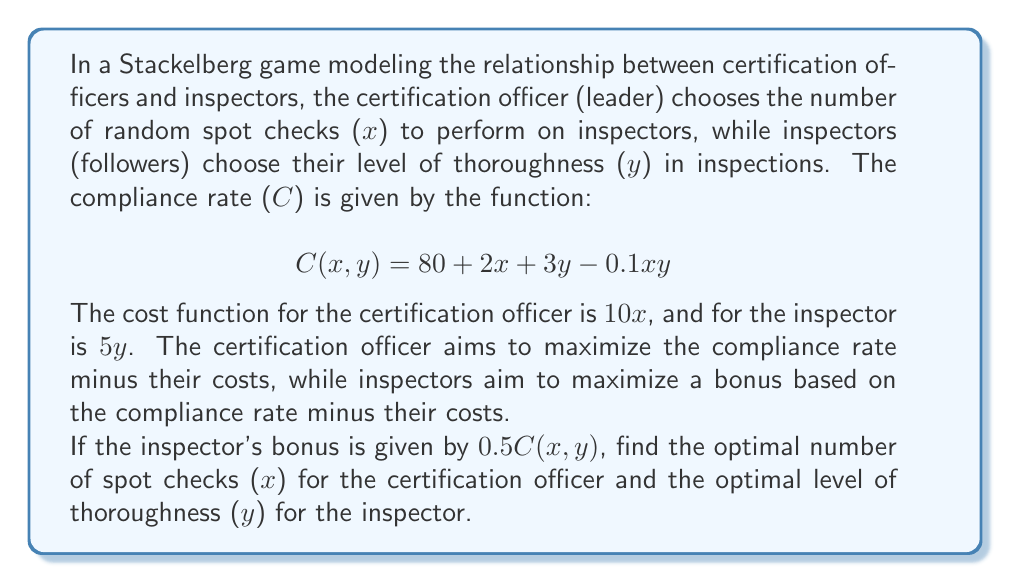What is the answer to this math problem? To solve this Stackelberg game, we use backward induction:

1) First, we determine the inspector's best response function:
   The inspector's utility function is:
   $$U_I(x,y) = 0.5C(x,y) - 5y = 0.5(80 + 2x + 3y - 0.1xy) - 5y$$
   
   To find the optimal $y$, we differentiate with respect to $y$ and set to zero:
   $$\frac{\partial U_I}{\partial y} = 0.5(3 - 0.1x) - 5 = 0$$
   $$1.5 - 0.05x = 5$$
   $$-0.05x = 3.5$$
   $$x = -70$$

   Since $x$ cannot be negative, the inspector's best response is:
   $$y^*(x) = \max\{0, 30 - 0.5x\}$$

2) Now, we solve the certification officer's problem:
   The certification officer's utility function is:
   $$U_C(x) = C(x,y^*(x)) - 10x$$
   
   Substituting $y^*(x) = 30 - 0.5x$ (assuming $x \leq 60$):
   $$U_C(x) = 80 + 2x + 3(30 - 0.5x) - 0.1x(30 - 0.5x) - 10x$$
   $$= 170 + 0.5x - 3x + 0.05x^2 - 10x$$
   $$= 170 - 12.5x + 0.05x^2$$

   To find the optimal $x$, we differentiate and set to zero:
   $$\frac{dU_C}{dx} = -12.5 + 0.1x = 0$$
   $$0.1x = 12.5$$
   $$x = 125$$

   However, this exceeds our assumption that $x \leq 60$. Therefore, we need to check the boundary at $x = 60$:
   
   At $x = 60$: $U_C(60) = 170 - 12.5(60) + 0.05(60)^2 = 350$
   At $x = 59$: $U_C(59) = 170 - 12.5(59) + 0.05(59)^2 = 349.95$

   Thus, the optimal solution for the certification officer is $x^* = 60$.

3) Given $x^* = 60$, we can now find the optimal $y$ for the inspector:
   $$y^* = 30 - 0.5(60) = 0$$

Therefore, the Stackelberg equilibrium is $(x^*, y^*) = (60, 0)$.
Answer: The optimal number of spot checks for the certification officer is $x^* = 60$, and the optimal level of thoroughness for the inspector is $y^* = 0$. 